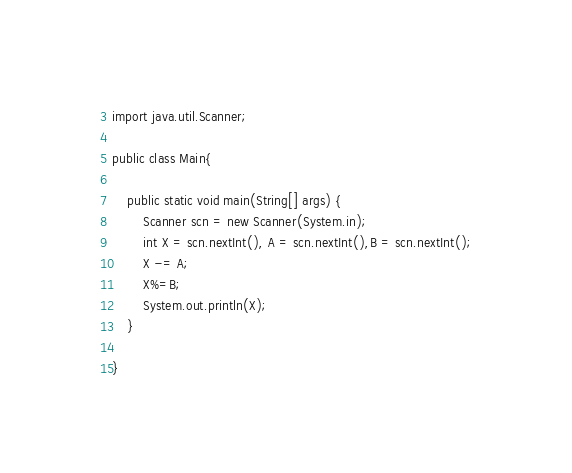Convert code to text. <code><loc_0><loc_0><loc_500><loc_500><_Java_>import java.util.Scanner;

public class Main{

	public static void main(String[] args) {
		Scanner scn = new Scanner(System.in);
		int X = scn.nextInt(), A = scn.nextInt(),B = scn.nextInt();
		X -= A;
		X%=B;
		System.out.println(X);
	}

}
</code> 